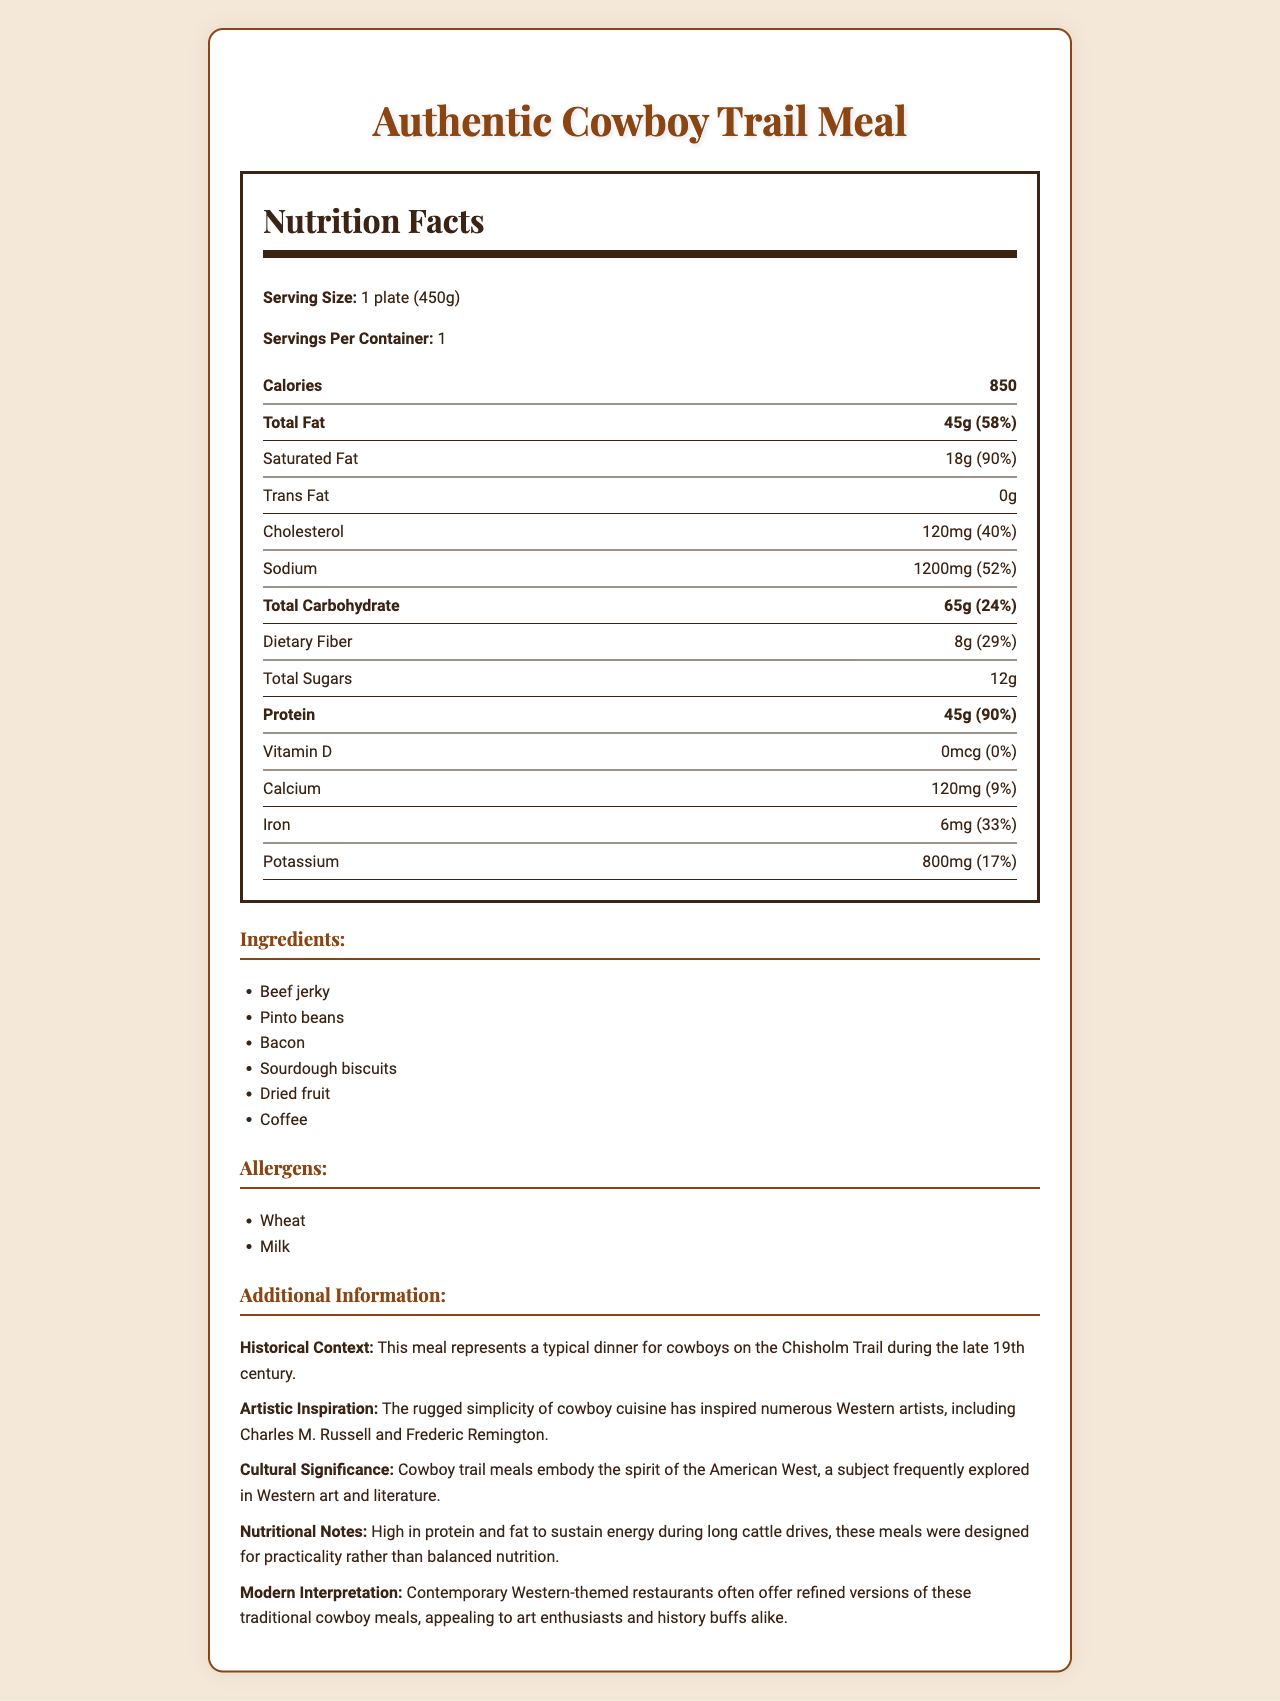what is the serving size for the "Authentic Cowboy Trail Meal"? The serving size is stated directly on the label.
Answer: 1 plate (450g) how many calories are in one serving of the meal? The calories per serving are listed as 850.
Answer: 850 what is the amount of total fat in grams? The total fat amount is given as 45 grams.
Answer: 45g how much dietary fiber does one serving contain? The dietary fiber content is listed as 8 grams.
Answer: 8g what percentage of the daily value of iron does the meal provide? The document states that the iron content is 33% of the daily value.
Answer: 33% which ingredient is not listed in the ingredients section? A. Dried fruit B. Bacon C. Cheese D. Pinto beans Cheese is not listed as an ingredient in the document.
Answer: C what is the daily value percentage of saturated fat? A. 18% B. 58% C. 29% D. 90% The daily value percentage for saturated fat is 90%.
Answer: D does the meal contain any trans fat? The document lists the amount of trans fat as 0g.
Answer: No does the meal contain any allergens? It lists wheat and milk as allergens.
Answer: Yes summarize the main idea of the document. The document covers various aspects of the "Authentic Cowboy Trail Meal," including its nutritional profile, ingredients, allergens, and relevant historical and cultural contexts.
Answer: The document provides a nutrition facts label for the "Authentic Cowboy Trail Meal," detailing its caloric content, macronutrient breakdown, vitamins, minerals, ingredients, allergens, and additional historical and cultural information. based on the historical context, which trail is the meal associated with? The document mentions that this meal represents a typical dinner for cowboys on the Chisholm Trail during the late 19th century.
Answer: The Chisholm Trail how much protein does the meal contain in grams? The protein content is listed as 45 grams in the document.
Answer: 45g what is the sodium content per serving? A. 52mg B. 1200mg C. 800mg D. 100mg The sodium content per serving is 1200mg.
Answer: B what is the artistic inspiration mentioned in the document? The artistic inspiration is described in the additional information section.
Answer: The rugged simplicity of cowboy cuisine has inspired numerous Western artists, including Charles M. Russell and Frederic Remington. how many servings are contained in one package? The servings per container is listed as 1.
Answer: 1 what key concept is explored frequently in Western art and literature, according to the document? The document states that cowboy trail meals embody the spirit of the American West, a subject frequently explored in Western art and literature.
Answer: The spirit of the American West what modern interpretation of cowboy trail meals is mentioned? The additional information section mentions the modern interpretation of these meals.
Answer: Contemporary Western-themed restaurants often offer refined versions of these traditional cowboy meals. is vitamin D present in this meal? The document lists 0 mcg of vitamin D, indicating its absence.
Answer: No which Western artists are inspired by cowboy cuisine? The document specifies these artists in the additional information section.
Answer: Charles M. Russell and Frederic Remington what type of coding information is used to generate this document? The document doesn't provide any coding details that were used to create it. This information is not visible in the document.
Answer: Cannot be determined 